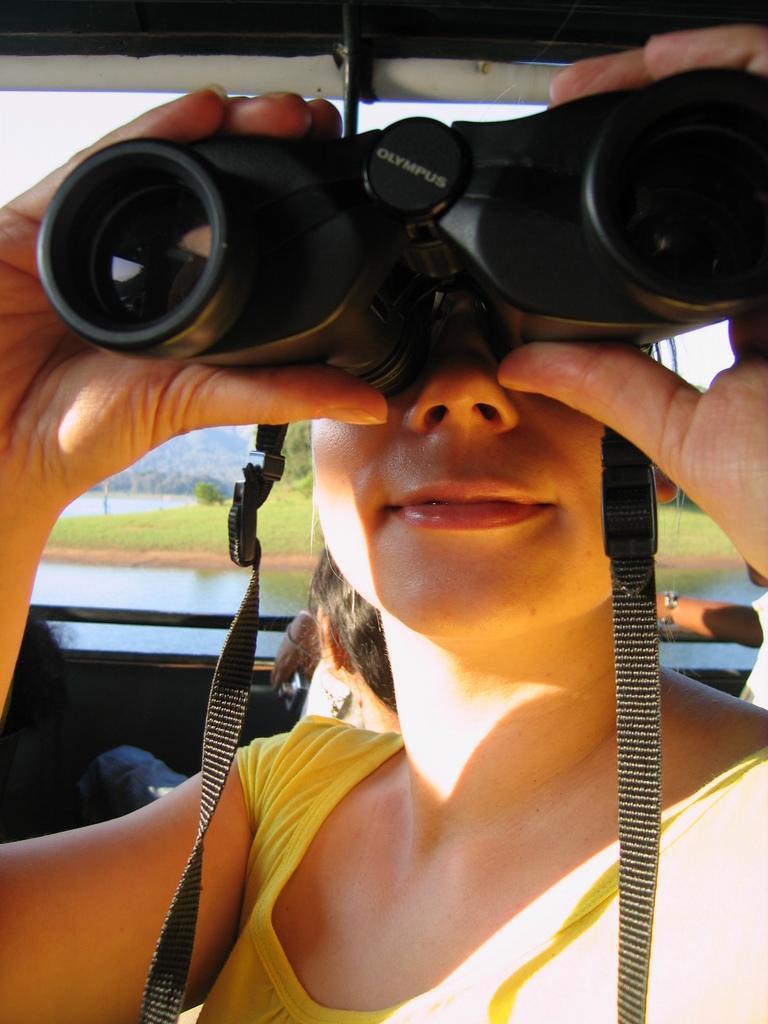Can you describe this image briefly? In the picture I can see a woman and she is holding the bioscope in her hands. I can see the hand of a person on the right side. In the background, I can see the water, green grass and trees. 